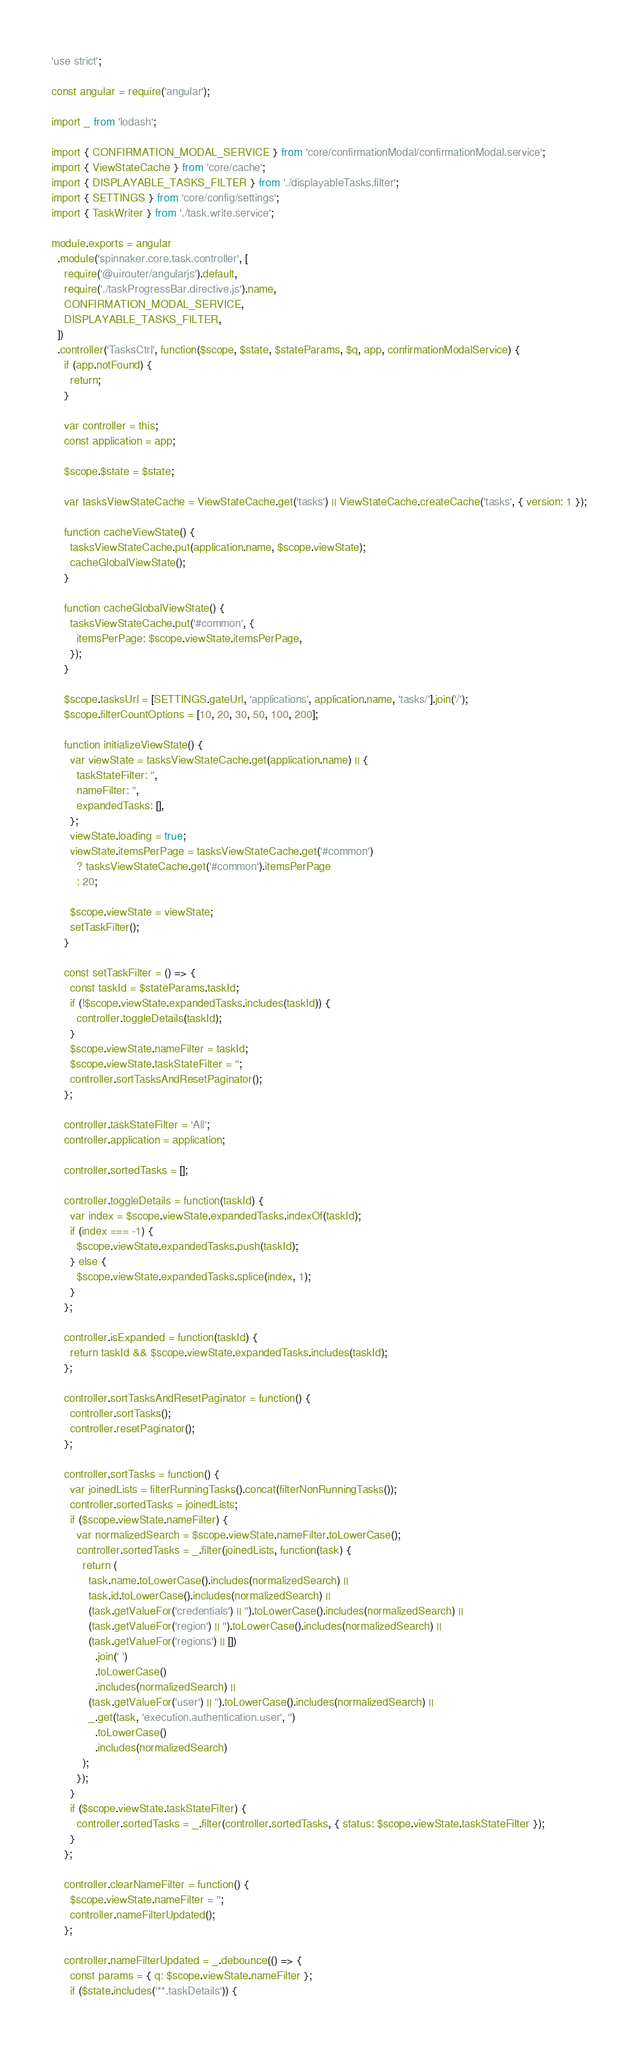Convert code to text. <code><loc_0><loc_0><loc_500><loc_500><_JavaScript_>'use strict';

const angular = require('angular');

import _ from 'lodash';

import { CONFIRMATION_MODAL_SERVICE } from 'core/confirmationModal/confirmationModal.service';
import { ViewStateCache } from 'core/cache';
import { DISPLAYABLE_TASKS_FILTER } from './displayableTasks.filter';
import { SETTINGS } from 'core/config/settings';
import { TaskWriter } from './task.write.service';

module.exports = angular
  .module('spinnaker.core.task.controller', [
    require('@uirouter/angularjs').default,
    require('./taskProgressBar.directive.js').name,
    CONFIRMATION_MODAL_SERVICE,
    DISPLAYABLE_TASKS_FILTER,
  ])
  .controller('TasksCtrl', function($scope, $state, $stateParams, $q, app, confirmationModalService) {
    if (app.notFound) {
      return;
    }

    var controller = this;
    const application = app;

    $scope.$state = $state;

    var tasksViewStateCache = ViewStateCache.get('tasks') || ViewStateCache.createCache('tasks', { version: 1 });

    function cacheViewState() {
      tasksViewStateCache.put(application.name, $scope.viewState);
      cacheGlobalViewState();
    }

    function cacheGlobalViewState() {
      tasksViewStateCache.put('#common', {
        itemsPerPage: $scope.viewState.itemsPerPage,
      });
    }

    $scope.tasksUrl = [SETTINGS.gateUrl, 'applications', application.name, 'tasks/'].join('/');
    $scope.filterCountOptions = [10, 20, 30, 50, 100, 200];

    function initializeViewState() {
      var viewState = tasksViewStateCache.get(application.name) || {
        taskStateFilter: '',
        nameFilter: '',
        expandedTasks: [],
      };
      viewState.loading = true;
      viewState.itemsPerPage = tasksViewStateCache.get('#common')
        ? tasksViewStateCache.get('#common').itemsPerPage
        : 20;

      $scope.viewState = viewState;
      setTaskFilter();
    }

    const setTaskFilter = () => {
      const taskId = $stateParams.taskId;
      if (!$scope.viewState.expandedTasks.includes(taskId)) {
        controller.toggleDetails(taskId);
      }
      $scope.viewState.nameFilter = taskId;
      $scope.viewState.taskStateFilter = '';
      controller.sortTasksAndResetPaginator();
    };

    controller.taskStateFilter = 'All';
    controller.application = application;

    controller.sortedTasks = [];

    controller.toggleDetails = function(taskId) {
      var index = $scope.viewState.expandedTasks.indexOf(taskId);
      if (index === -1) {
        $scope.viewState.expandedTasks.push(taskId);
      } else {
        $scope.viewState.expandedTasks.splice(index, 1);
      }
    };

    controller.isExpanded = function(taskId) {
      return taskId && $scope.viewState.expandedTasks.includes(taskId);
    };

    controller.sortTasksAndResetPaginator = function() {
      controller.sortTasks();
      controller.resetPaginator();
    };

    controller.sortTasks = function() {
      var joinedLists = filterRunningTasks().concat(filterNonRunningTasks());
      controller.sortedTasks = joinedLists;
      if ($scope.viewState.nameFilter) {
        var normalizedSearch = $scope.viewState.nameFilter.toLowerCase();
        controller.sortedTasks = _.filter(joinedLists, function(task) {
          return (
            task.name.toLowerCase().includes(normalizedSearch) ||
            task.id.toLowerCase().includes(normalizedSearch) ||
            (task.getValueFor('credentials') || '').toLowerCase().includes(normalizedSearch) ||
            (task.getValueFor('region') || '').toLowerCase().includes(normalizedSearch) ||
            (task.getValueFor('regions') || [])
              .join(' ')
              .toLowerCase()
              .includes(normalizedSearch) ||
            (task.getValueFor('user') || '').toLowerCase().includes(normalizedSearch) ||
            _.get(task, 'execution.authentication.user', '')
              .toLowerCase()
              .includes(normalizedSearch)
          );
        });
      }
      if ($scope.viewState.taskStateFilter) {
        controller.sortedTasks = _.filter(controller.sortedTasks, { status: $scope.viewState.taskStateFilter });
      }
    };

    controller.clearNameFilter = function() {
      $scope.viewState.nameFilter = '';
      controller.nameFilterUpdated();
    };

    controller.nameFilterUpdated = _.debounce(() => {
      const params = { q: $scope.viewState.nameFilter };
      if ($state.includes('**.taskDetails')) {</code> 